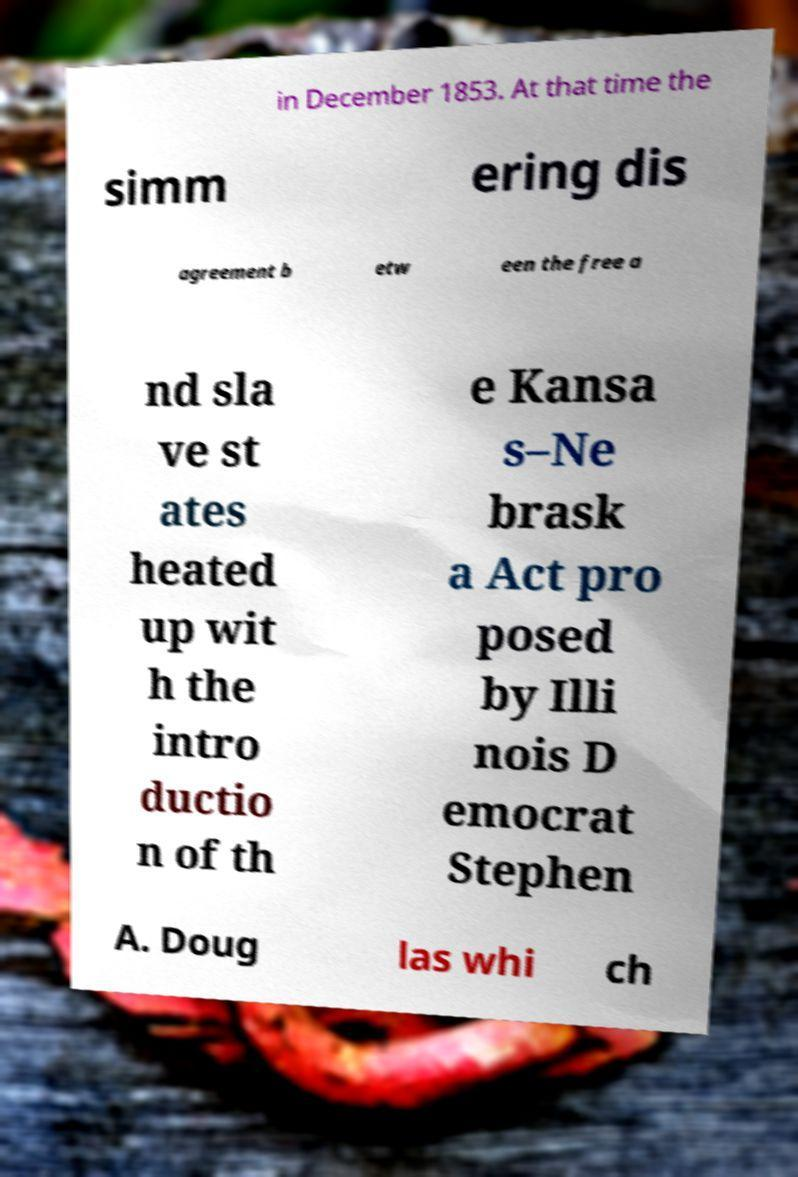For documentation purposes, I need the text within this image transcribed. Could you provide that? in December 1853. At that time the simm ering dis agreement b etw een the free a nd sla ve st ates heated up wit h the intro ductio n of th e Kansa s–Ne brask a Act pro posed by Illi nois D emocrat Stephen A. Doug las whi ch 